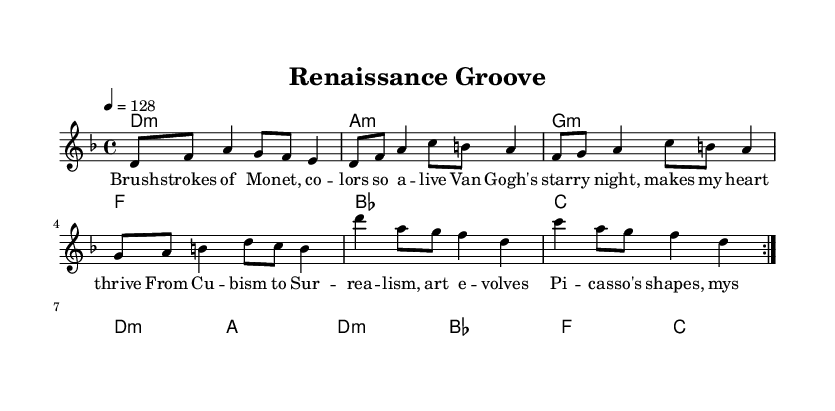What is the key signature of this music? The key signature indicates D minor, which has one flat (B flat). This is determined by the "d" at the beginning of the score and the presence of the flat sign throughout the sheet music.
Answer: D minor What is the time signature of the piece? The time signature is 4/4, which means there are four beats per measure and the quarter note gets one beat. This is indicated by the "4/4" notation found at the beginning of the score.
Answer: 4/4 What is the tempo marking of this piece? The tempo marking is set at 128 beats per minute, as indicated by the "4 = 128" which tells musicians how fast the piece should be played.
Answer: 128 Which art movement is referenced in the lyrics? The lyrics reference the Renaissance art movement, as indicated by the positive connotations associated with the word "groove" linked to artistic themes of that era.
Answer: Renaissance How many times is the melody repeated? The melody is repeated two times as shown by the "repeat volta 2" indication at the beginning of the melody section, telling performers to go through that section twice.
Answer: 2 What is the prominent theme in the lyrics? The lyrics prominently highlight famous artists and their contributions to art, with specific references to Van Gogh, Picasso, and the evolution of art movements, which reflects a narrative connection to the historical significance of art.
Answer: Famous artists What genre does this piece represent? The piece represents K-pop, identifiable by its upbeat tempo, modern lyrical content interwoven with historical references, and the use of harmony and melody commonly found in the genre.
Answer: K-pop 